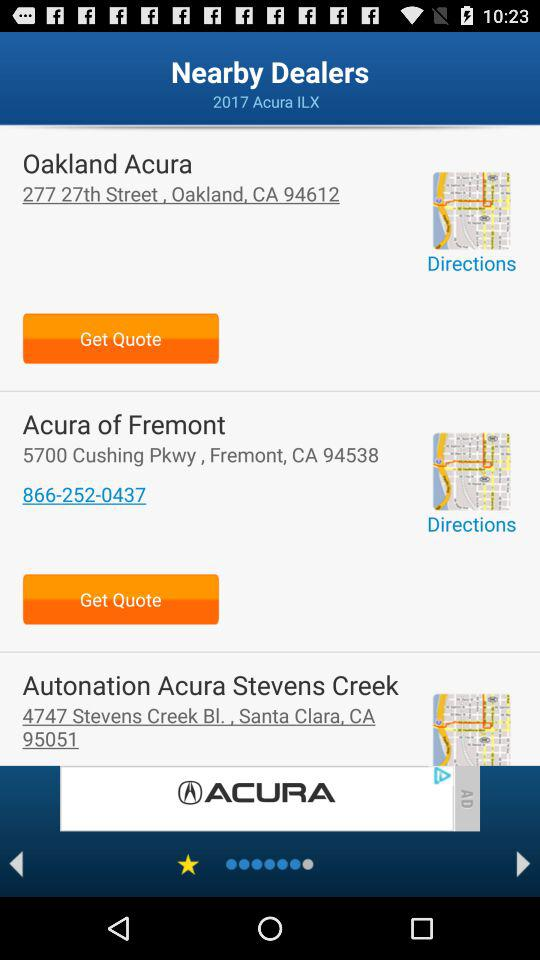What is the phone number for "Acura of Fremont"? The phone number for "Acura of Fremont" is 866-252-0437. 